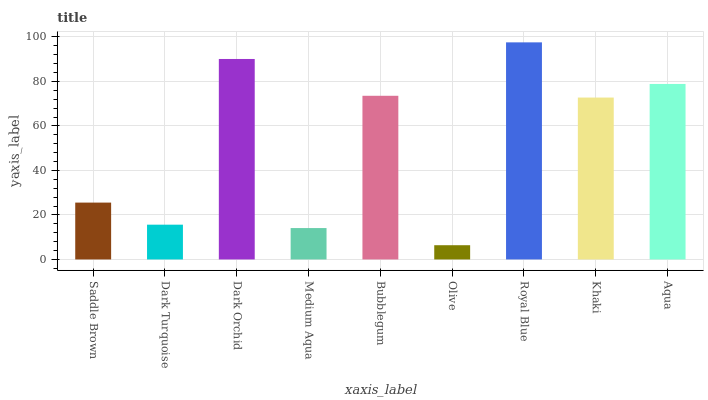Is Olive the minimum?
Answer yes or no. Yes. Is Royal Blue the maximum?
Answer yes or no. Yes. Is Dark Turquoise the minimum?
Answer yes or no. No. Is Dark Turquoise the maximum?
Answer yes or no. No. Is Saddle Brown greater than Dark Turquoise?
Answer yes or no. Yes. Is Dark Turquoise less than Saddle Brown?
Answer yes or no. Yes. Is Dark Turquoise greater than Saddle Brown?
Answer yes or no. No. Is Saddle Brown less than Dark Turquoise?
Answer yes or no. No. Is Khaki the high median?
Answer yes or no. Yes. Is Khaki the low median?
Answer yes or no. Yes. Is Olive the high median?
Answer yes or no. No. Is Bubblegum the low median?
Answer yes or no. No. 